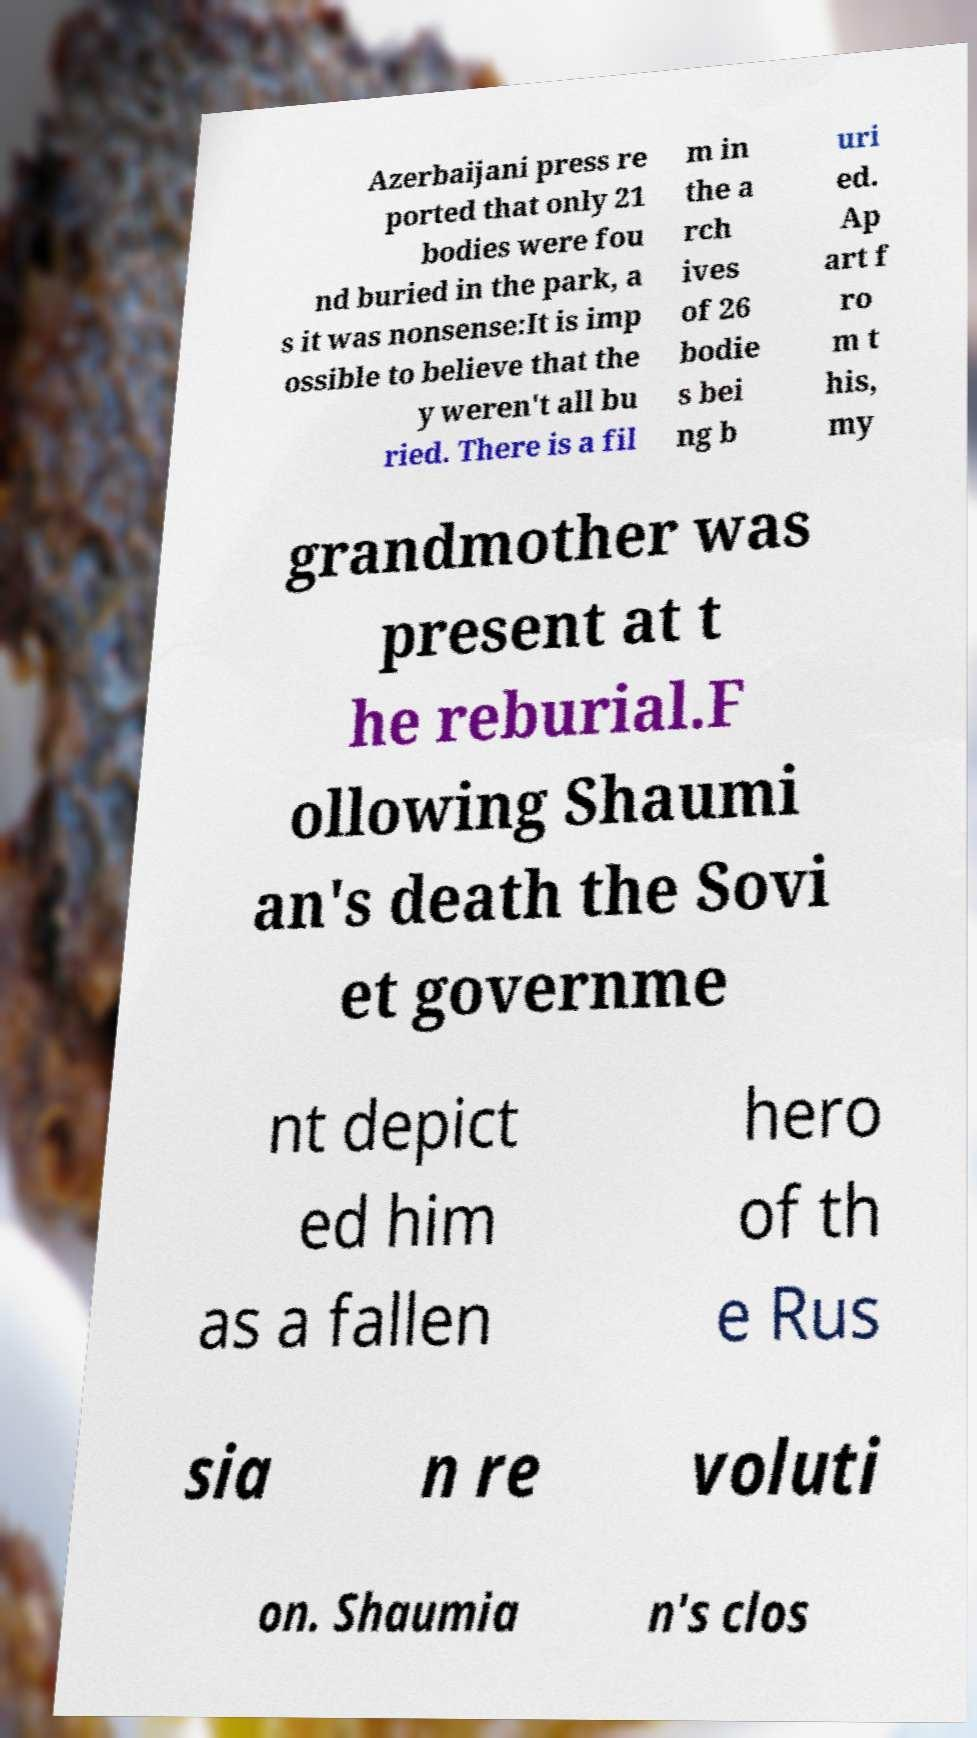Can you accurately transcribe the text from the provided image for me? Azerbaijani press re ported that only 21 bodies were fou nd buried in the park, a s it was nonsense:It is imp ossible to believe that the y weren't all bu ried. There is a fil m in the a rch ives of 26 bodie s bei ng b uri ed. Ap art f ro m t his, my grandmother was present at t he reburial.F ollowing Shaumi an's death the Sovi et governme nt depict ed him as a fallen hero of th e Rus sia n re voluti on. Shaumia n's clos 